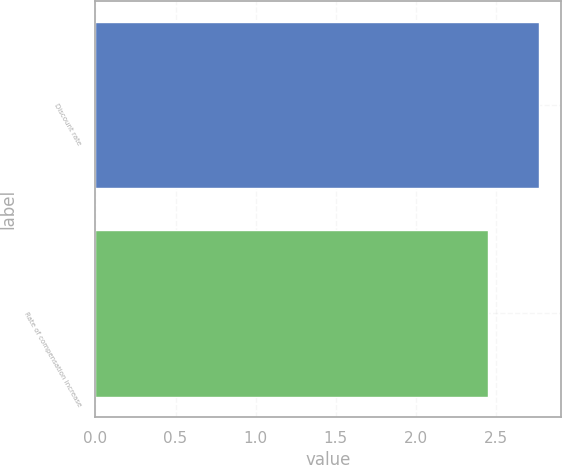<chart> <loc_0><loc_0><loc_500><loc_500><bar_chart><fcel>Discount rate<fcel>Rate of compensation increase<nl><fcel>2.77<fcel>2.45<nl></chart> 